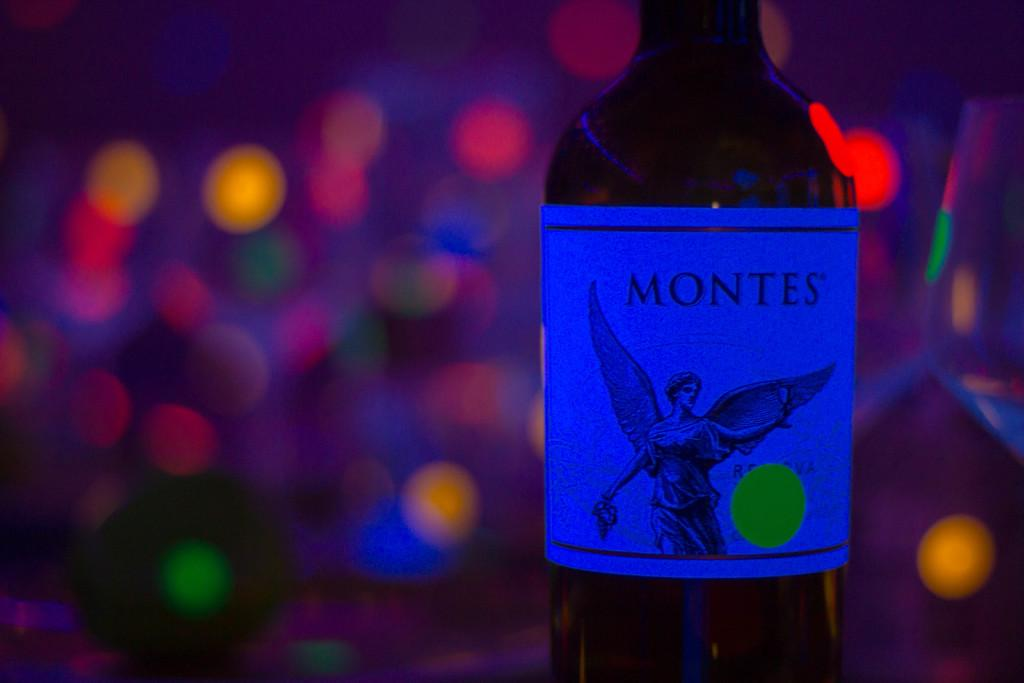<image>
Summarize the visual content of the image. A bottle of Montes has an angel on the label. 